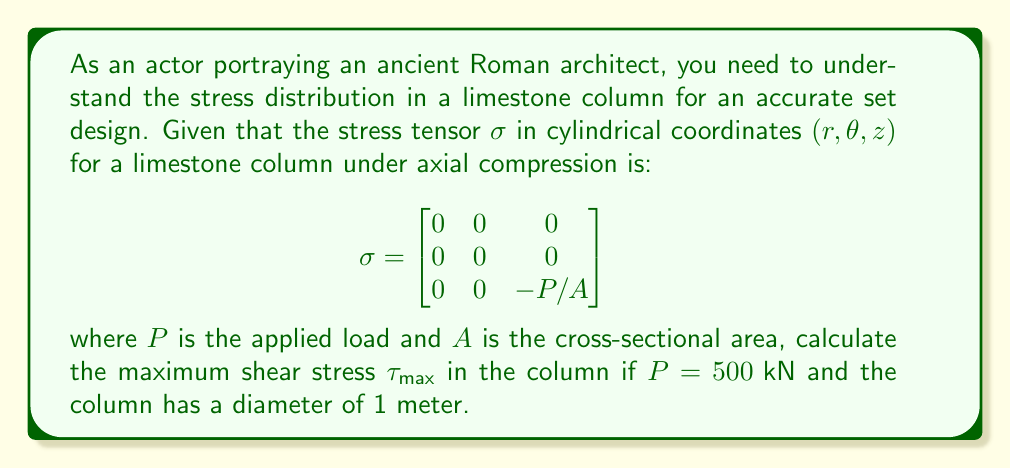Solve this math problem. To solve this problem, we'll follow these steps:

1) First, recall that the maximum shear stress $\tau_{max}$ is given by half the difference between the maximum and minimum principal stresses:

   $$\tau_{max} = \frac{1}{2}(\sigma_{max} - \sigma_{min})$$

2) From the given stress tensor, we can identify the principal stresses:
   $\sigma_1 = \sigma_2 = 0$ and $\sigma_3 = -P/A$

3) Calculate the cross-sectional area $A$:
   $$A = \pi r^2 = \pi (0.5 \text{ m})^2 = 0.7854 \text{ m}^2$$

4) Calculate $\sigma_3$:
   $$\sigma_3 = -P/A = -\frac{500 \text{ kN}}{0.7854 \text{ m}^2} = -636.62 \text{ kPa}$$

5) Now we can calculate $\tau_{max}$:
   $$\tau_{max} = \frac{1}{2}(0 - (-636.62 \text{ kPa})) = 318.31 \text{ kPa}$$

Therefore, the maximum shear stress in the limestone column is 318.31 kPa.
Answer: $318.31 \text{ kPa}$ 